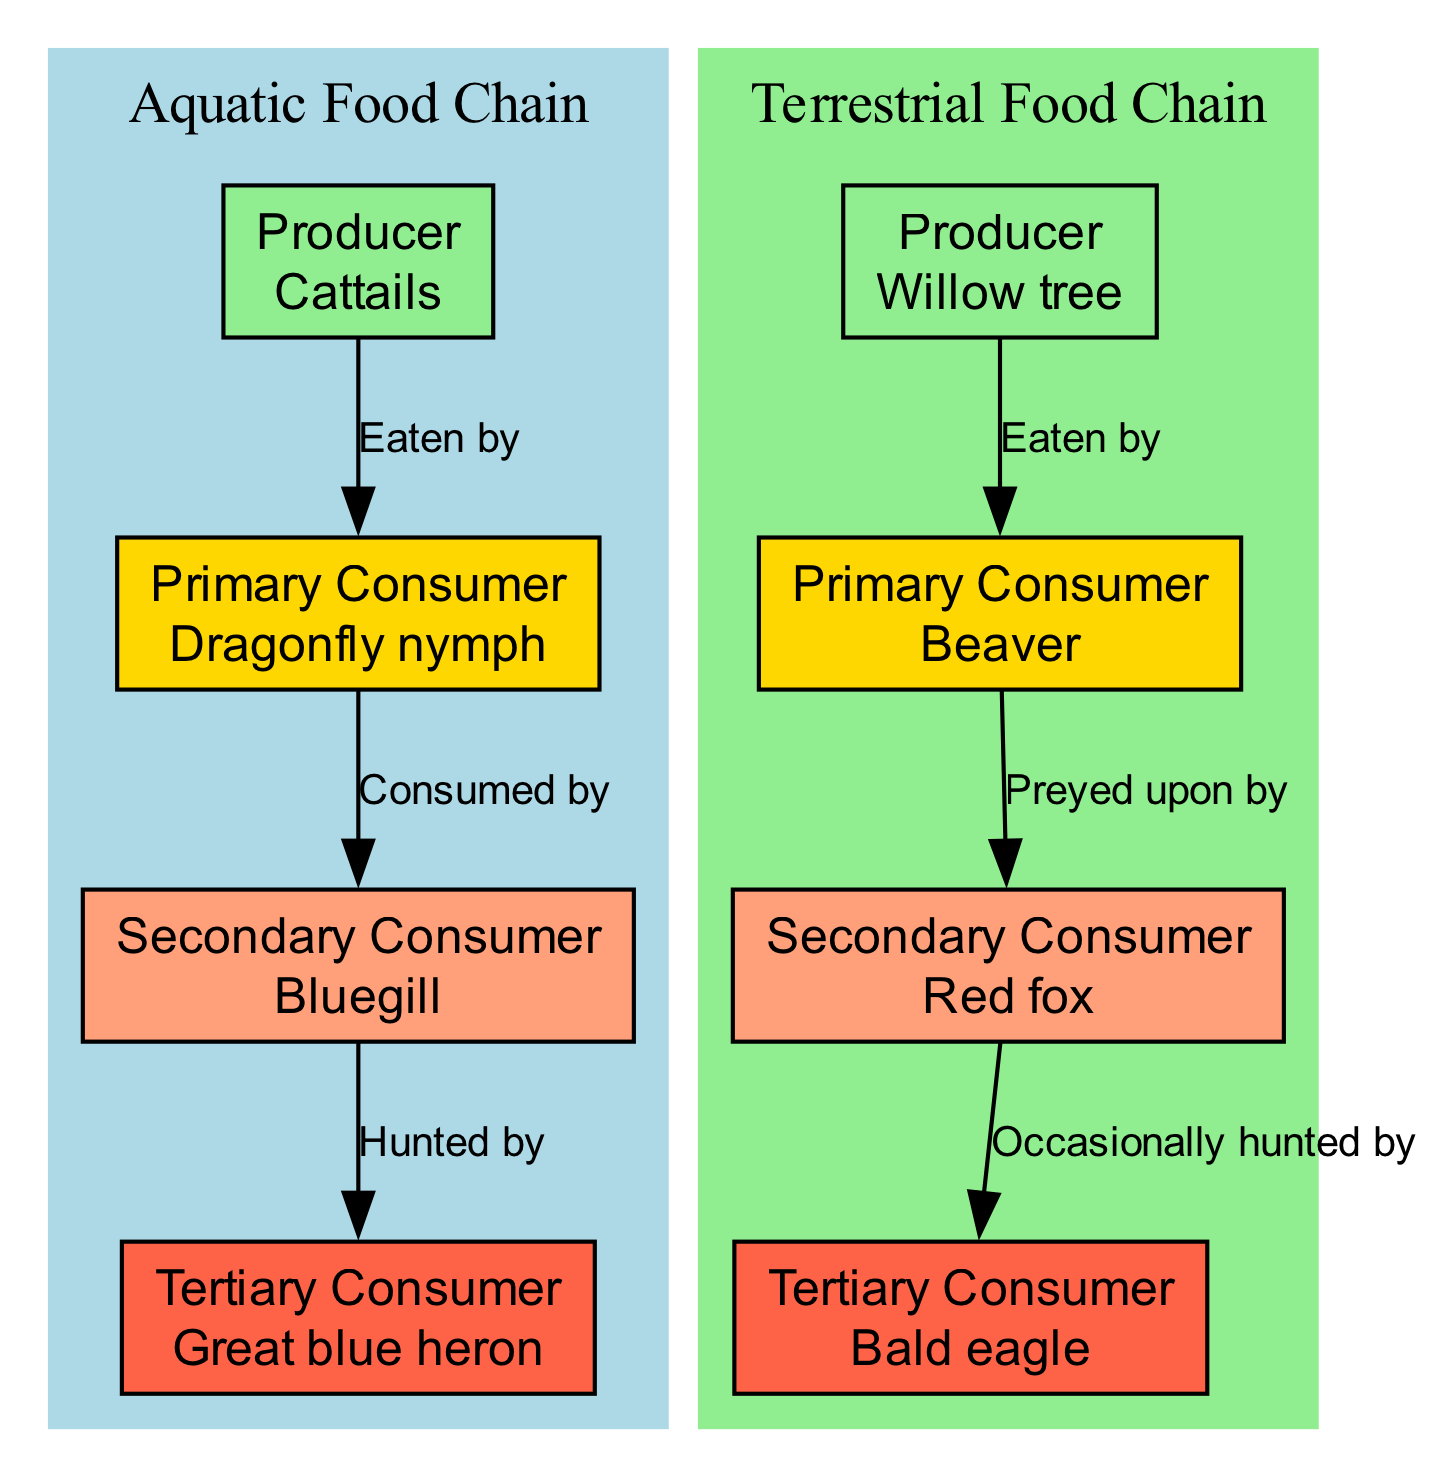What is the primary producer in the aquatic food chain? The diagram indicates that Cattails are the primary producers in the aquatic food chain. This can be confirmed by looking at the 'Producer' level in the aquaticChain section.
Answer: Cattails How many nodes are present in the terrestrial food chain? In the terrestrial food chain, we can count the nodes: Willow tree (Producer), Beaver (Primary Consumer), Red fox (Secondary Consumer), and Bald eagle (Tertiary Consumer). This sums up to four nodes.
Answer: 4 Who is the tertiary consumer in the aquatic food chain? The tertiary consumer in the aquatic chain is the Great blue heron. This is explicitly stated in the aquaticChain section, where it identifies the levels and organisms.
Answer: Great blue heron What type of relationship exists between the Beaver and the Red fox? The relationship between the Beaver and the Red fox is characterized by predation, as indicated by the label "Preyed upon by" on the edge connecting these two nodes.
Answer: Preyed upon by Which consumer is often hunted by the Bald eagle? According to the connections in the diagram, the Red fox is occasionally hunted by the Bald eagle. This is derived from the statement provided on the edge connecting these two organisms.
Answer: Red fox What color represents the producer level in the diagram? The producer level is represented in the diagram by the color green. This can be derived from the color coding explained in the get_color function.
Answer: Green How many connections are there in total between nodes in the aquatic food chain? Counting the connections in the aquatic food chain shows three arrows: from Cattails to Dragonfly nymph, from Dragonfly nymph to Bluegill, and from Bluegill to Great blue heron. Thus, there are three connections.
Answer: 3 What is the primary consumer in the terrestrial food chain? The primary consumer is Beaver, which is listed as the organism following the 'Producer' level represented by the Willow tree in the terrestrialChain section.
Answer: Beaver How do Dragonfly nymphs impact Bluegill populations? Dragonfly nymphs serve as prey for Bluegills, which means they impact Bluegill populations by being a food source, as denoted by the edge labeled "Consumed by" in the connections.
Answer: Eaten by 